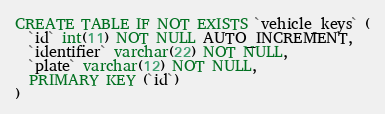Convert code to text. <code><loc_0><loc_0><loc_500><loc_500><_SQL_>CREATE TABLE IF NOT EXISTS `vehicle_keys` (
  `id` int(11) NOT NULL AUTO_INCREMENT,
  `identifier` varchar(22) NOT NULL,
  `plate` varchar(12) NOT NULL,
  PRIMARY KEY (`id`)
)
</code> 